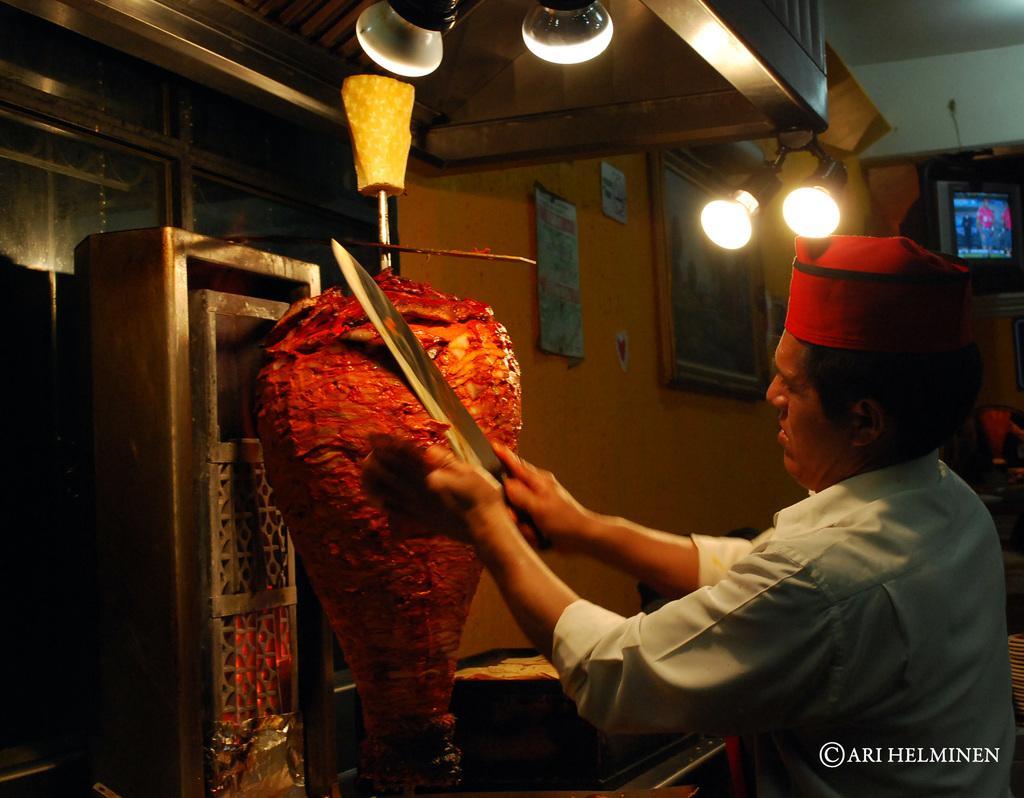Can you describe this image briefly? On the right side of the image we can see a man, he is holding a knife, in front of him we can see meat, in the background we can find few lights, television and few frames on the wall, at the right bottom of the image we can see some text. 